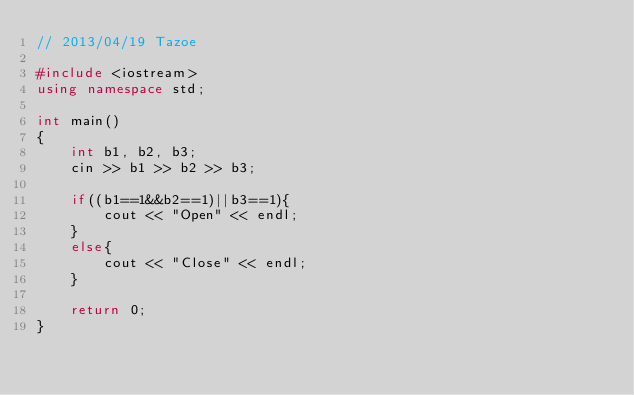Convert code to text. <code><loc_0><loc_0><loc_500><loc_500><_C++_>// 2013/04/19 Tazoe

#include <iostream>
using namespace std;

int main()
{
	int b1, b2, b3;
	cin >> b1 >> b2 >> b3;

	if((b1==1&&b2==1)||b3==1){
		cout << "Open" << endl;
	}
	else{
		cout << "Close" << endl;
	}

	return 0;
}</code> 